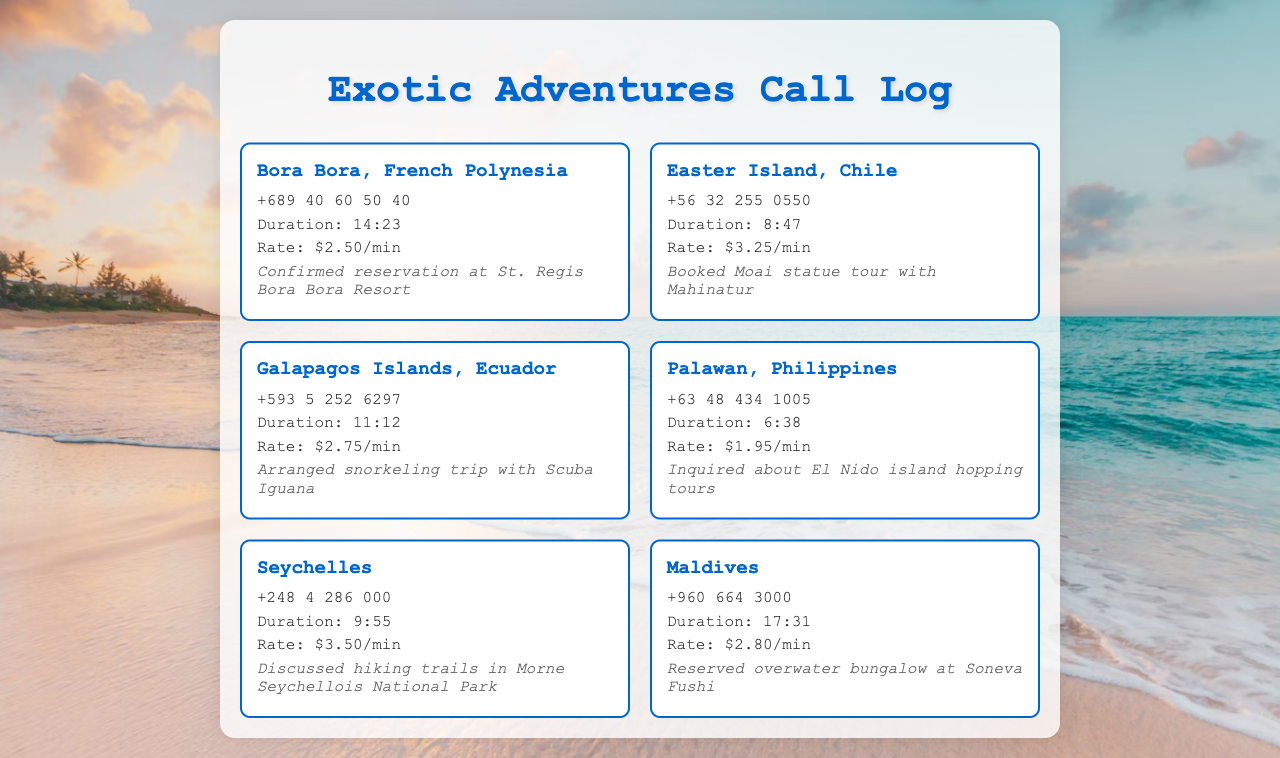What is the destination for the shortest call? The shortest call is to Palawan, Philippines, with a duration of 6:38.
Answer: Palawan, Philippines What is the rate per minute to call Seychelles? The rate for calling Seychelles is mentioned in the document as $3.50/min.
Answer: $3.50/min How long was the call to Maldives? The duration of the call to Maldives is specified as 17:31.
Answer: 17:31 Which destination has the highest calling rate? Easter Island, Chile has the highest calling rate listed at $3.25/min.
Answer: Easter Island, Chile What was discussed during the call to Bora Bora? The notes mention a confirmed reservation at St. Regis Bora Bora Resort.
Answer: Confirmed reservation at St. Regis Bora Bora Resort What is the contact number for Galapagos Islands? The document provides the number as +593 5 252 6297.
Answer: +593 5 252 6297 Which destination has the longest call duration? The longest call listed is to Maldives at 17:31.
Answer: Maldives What type of trip was arranged for the Galapagos Islands? The notes state a snorkeling trip was arranged with Scuba Iguana.
Answer: Snorkeling trip What is the duration of the call to Easter Island? The call duration to Easter Island is noted as 8:47.
Answer: 8:47 